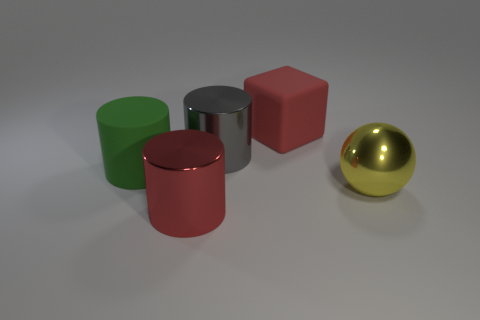The big gray object has what shape?
Your response must be concise. Cylinder. The thing that is the same color as the cube is what size?
Provide a short and direct response. Large. There is a shiny cylinder that is behind the red metallic object; what number of red objects are in front of it?
Your answer should be compact. 1. What number of other objects are there of the same material as the green thing?
Provide a succinct answer. 1. Is the large cylinder in front of the large sphere made of the same material as the big gray thing that is on the right side of the big matte cylinder?
Provide a succinct answer. Yes. Is there anything else that is the same shape as the red rubber thing?
Your answer should be compact. No. Does the big yellow thing have the same material as the red thing that is to the left of the red rubber block?
Provide a succinct answer. Yes. The object that is in front of the metal thing that is on the right side of the big thing that is behind the big gray object is what color?
Ensure brevity in your answer.  Red. The green rubber object that is the same size as the yellow thing is what shape?
Make the answer very short. Cylinder. Is there anything else that is the same size as the cube?
Your answer should be compact. Yes. 